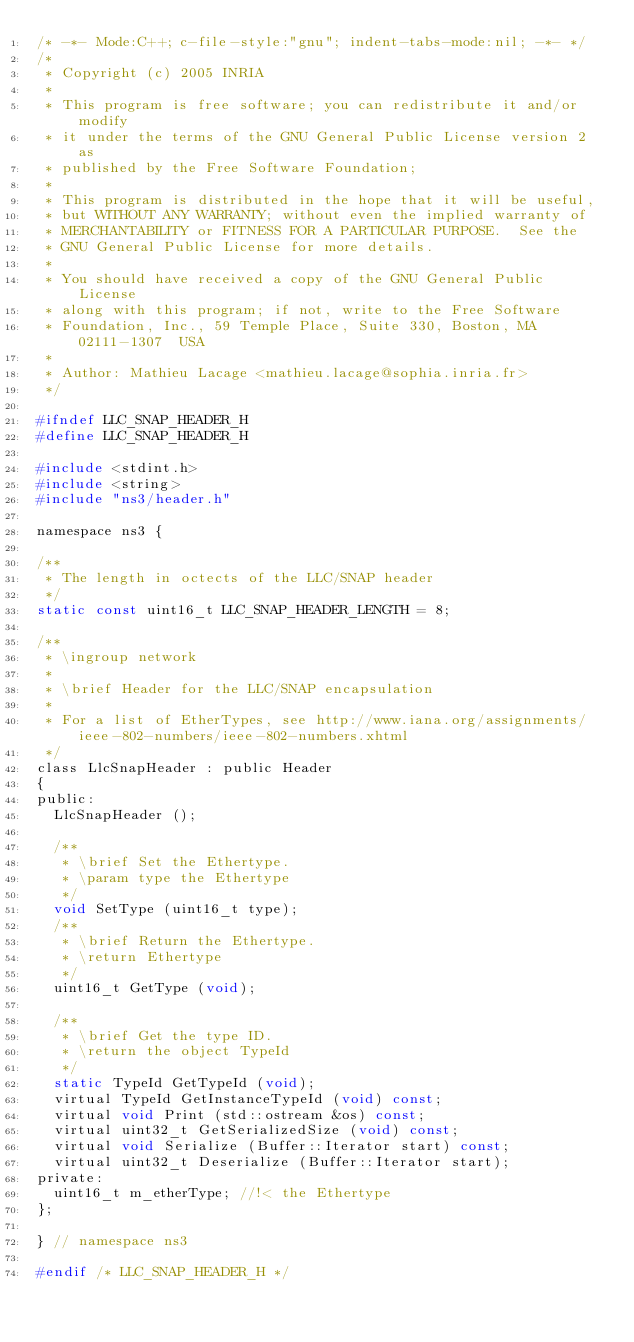Convert code to text. <code><loc_0><loc_0><loc_500><loc_500><_C_>/* -*- Mode:C++; c-file-style:"gnu"; indent-tabs-mode:nil; -*- */
/*
 * Copyright (c) 2005 INRIA
 *
 * This program is free software; you can redistribute it and/or modify
 * it under the terms of the GNU General Public License version 2 as
 * published by the Free Software Foundation;
 *
 * This program is distributed in the hope that it will be useful,
 * but WITHOUT ANY WARRANTY; without even the implied warranty of
 * MERCHANTABILITY or FITNESS FOR A PARTICULAR PURPOSE.  See the
 * GNU General Public License for more details.
 *
 * You should have received a copy of the GNU General Public License
 * along with this program; if not, write to the Free Software
 * Foundation, Inc., 59 Temple Place, Suite 330, Boston, MA  02111-1307  USA
 *
 * Author: Mathieu Lacage <mathieu.lacage@sophia.inria.fr>
 */

#ifndef LLC_SNAP_HEADER_H
#define LLC_SNAP_HEADER_H

#include <stdint.h>
#include <string>
#include "ns3/header.h"

namespace ns3 {

/** 
 * The length in octects of the LLC/SNAP header
 */
static const uint16_t LLC_SNAP_HEADER_LENGTH = 8;

/**
 * \ingroup network
 *
 * \brief Header for the LLC/SNAP encapsulation
 *
 * For a list of EtherTypes, see http://www.iana.org/assignments/ieee-802-numbers/ieee-802-numbers.xhtml
 */
class LlcSnapHeader : public Header 
{
public:
  LlcSnapHeader ();

  /**
   * \brief Set the Ethertype.
   * \param type the Ethertype
   */
  void SetType (uint16_t type);
  /**
   * \brief Return the Ethertype.
   * \return Ethertype
   */
  uint16_t GetType (void);

  /**
   * \brief Get the type ID.
   * \return the object TypeId
   */
  static TypeId GetTypeId (void);
  virtual TypeId GetInstanceTypeId (void) const;
  virtual void Print (std::ostream &os) const;
  virtual uint32_t GetSerializedSize (void) const;
  virtual void Serialize (Buffer::Iterator start) const;
  virtual uint32_t Deserialize (Buffer::Iterator start);
private:
  uint16_t m_etherType; //!< the Ethertype
};

} // namespace ns3

#endif /* LLC_SNAP_HEADER_H */
</code> 